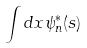<formula> <loc_0><loc_0><loc_500><loc_500>\int d x \psi _ { n } ^ { * } ( s )</formula> 